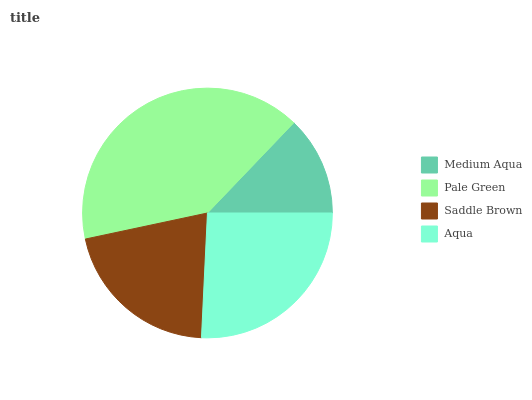Is Medium Aqua the minimum?
Answer yes or no. Yes. Is Pale Green the maximum?
Answer yes or no. Yes. Is Saddle Brown the minimum?
Answer yes or no. No. Is Saddle Brown the maximum?
Answer yes or no. No. Is Pale Green greater than Saddle Brown?
Answer yes or no. Yes. Is Saddle Brown less than Pale Green?
Answer yes or no. Yes. Is Saddle Brown greater than Pale Green?
Answer yes or no. No. Is Pale Green less than Saddle Brown?
Answer yes or no. No. Is Aqua the high median?
Answer yes or no. Yes. Is Saddle Brown the low median?
Answer yes or no. Yes. Is Medium Aqua the high median?
Answer yes or no. No. Is Pale Green the low median?
Answer yes or no. No. 